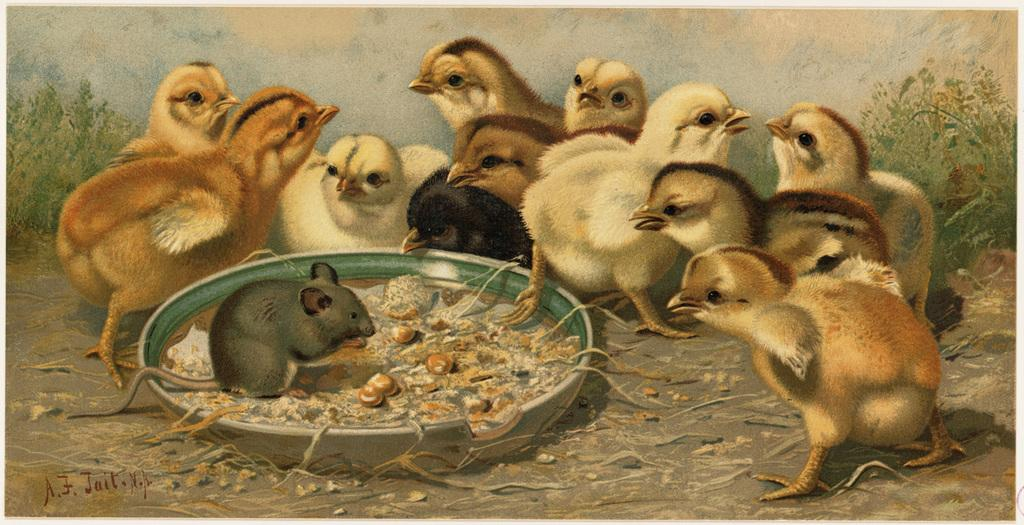What type of animals are in the image? There is a group of pets in the image. What can be seen on the right side of the image? There are plants on the right side of the image. What can be seen on the left side of the image? There are plants on the left side of the image. What type of dress is the person wearing in the image? There is no person present in the image, so it is not possible to determine what type of dress they might be wearing. 